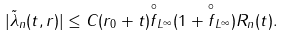Convert formula to latex. <formula><loc_0><loc_0><loc_500><loc_500>| \tilde { \lambda } _ { n } ( t , r ) | \leq C ( r _ { 0 } + t ) \| \overset { \circ } { f } \| _ { L ^ { \infty } } ( 1 + \| \overset { \circ } { f } \| _ { L ^ { \infty } } ) R _ { n } ( t ) .</formula> 